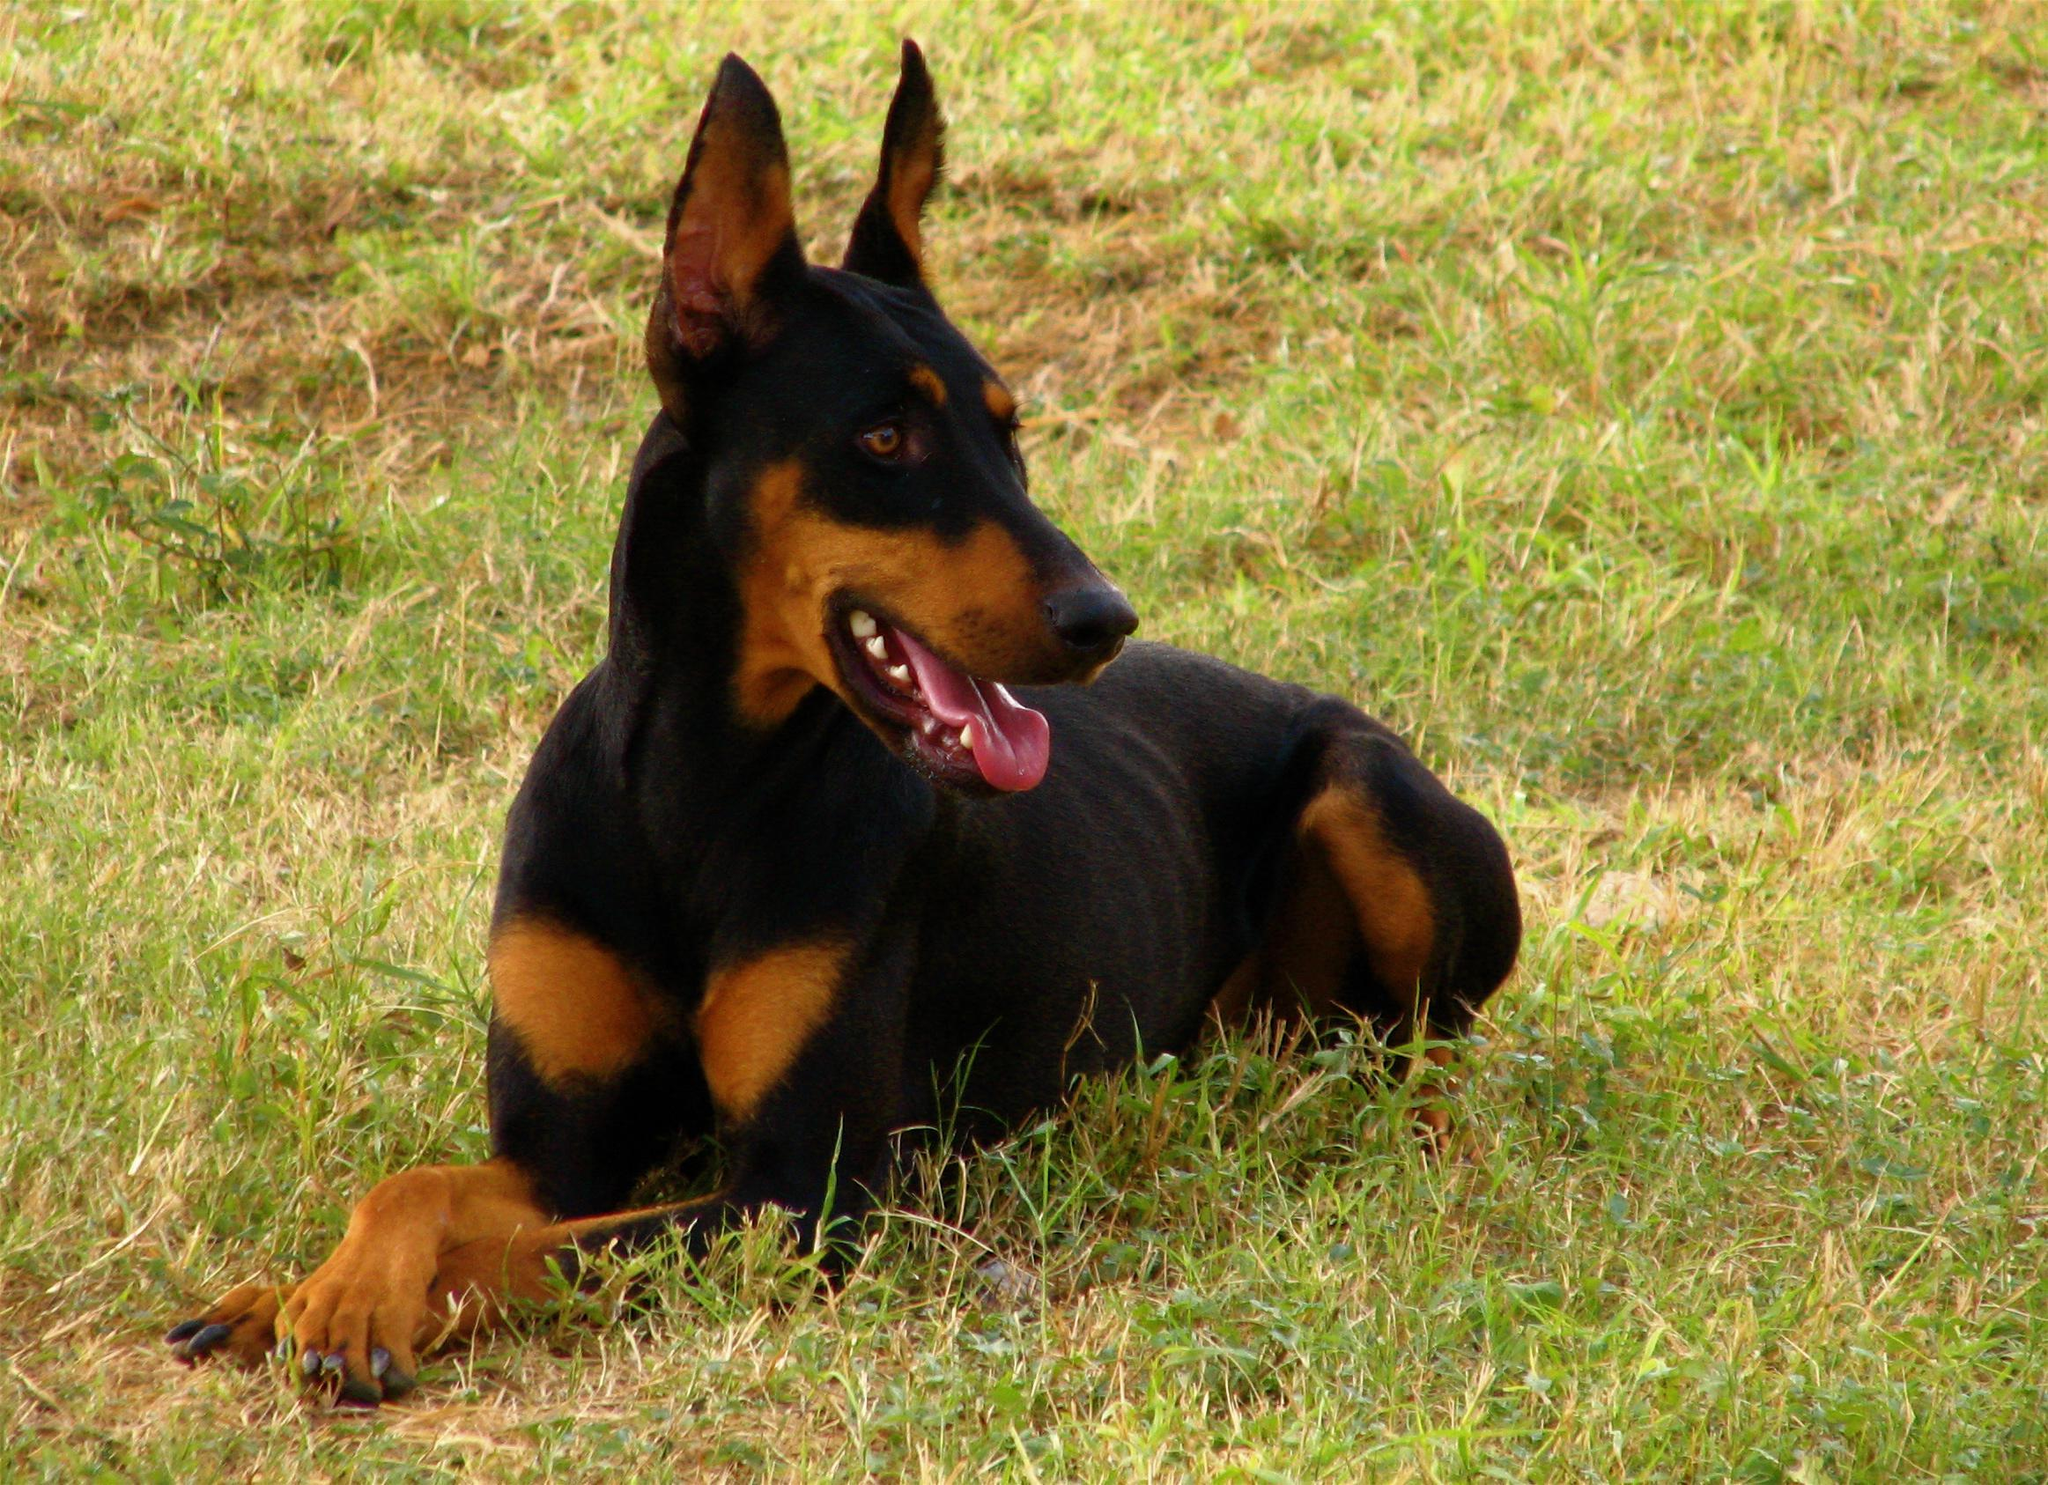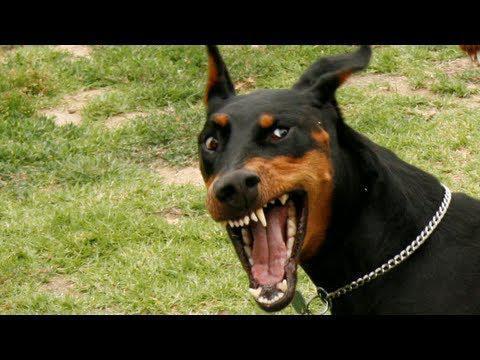The first image is the image on the left, the second image is the image on the right. Considering the images on both sides, is "One of the dogs is standing with its head facing left." valid? Answer yes or no. No. The first image is the image on the left, the second image is the image on the right. For the images displayed, is the sentence "One image shows a doberman with erect ears and docked tail standing in profile facing left, and the other image shows a non-standing doberman wearing a collar." factually correct? Answer yes or no. No. 